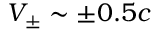Convert formula to latex. <formula><loc_0><loc_0><loc_500><loc_500>V _ { \pm } \sim \pm 0 . 5 c</formula> 